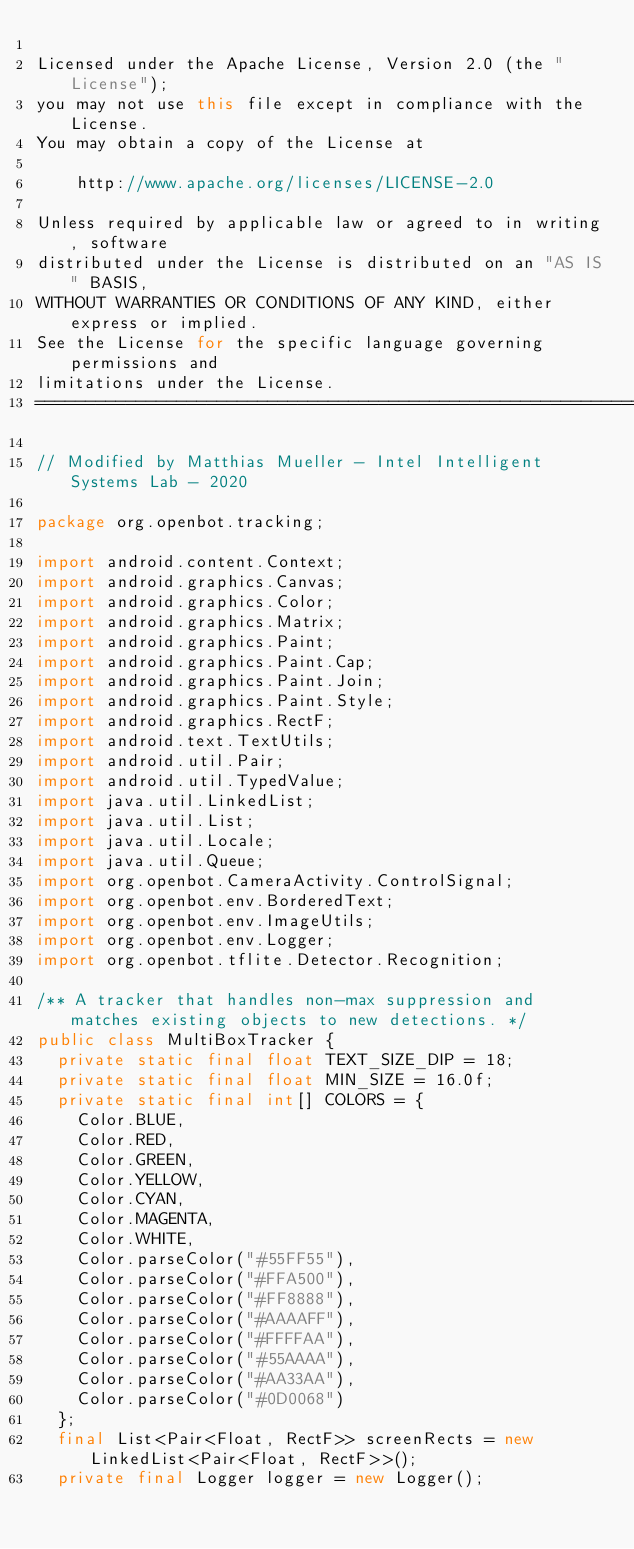<code> <loc_0><loc_0><loc_500><loc_500><_Java_>
Licensed under the Apache License, Version 2.0 (the "License");
you may not use this file except in compliance with the License.
You may obtain a copy of the License at

    http://www.apache.org/licenses/LICENSE-2.0

Unless required by applicable law or agreed to in writing, software
distributed under the License is distributed on an "AS IS" BASIS,
WITHOUT WARRANTIES OR CONDITIONS OF ANY KIND, either express or implied.
See the License for the specific language governing permissions and
limitations under the License.
==============================================================================*/

// Modified by Matthias Mueller - Intel Intelligent Systems Lab - 2020

package org.openbot.tracking;

import android.content.Context;
import android.graphics.Canvas;
import android.graphics.Color;
import android.graphics.Matrix;
import android.graphics.Paint;
import android.graphics.Paint.Cap;
import android.graphics.Paint.Join;
import android.graphics.Paint.Style;
import android.graphics.RectF;
import android.text.TextUtils;
import android.util.Pair;
import android.util.TypedValue;
import java.util.LinkedList;
import java.util.List;
import java.util.Locale;
import java.util.Queue;
import org.openbot.CameraActivity.ControlSignal;
import org.openbot.env.BorderedText;
import org.openbot.env.ImageUtils;
import org.openbot.env.Logger;
import org.openbot.tflite.Detector.Recognition;

/** A tracker that handles non-max suppression and matches existing objects to new detections. */
public class MultiBoxTracker {
  private static final float TEXT_SIZE_DIP = 18;
  private static final float MIN_SIZE = 16.0f;
  private static final int[] COLORS = {
    Color.BLUE,
    Color.RED,
    Color.GREEN,
    Color.YELLOW,
    Color.CYAN,
    Color.MAGENTA,
    Color.WHITE,
    Color.parseColor("#55FF55"),
    Color.parseColor("#FFA500"),
    Color.parseColor("#FF8888"),
    Color.parseColor("#AAAAFF"),
    Color.parseColor("#FFFFAA"),
    Color.parseColor("#55AAAA"),
    Color.parseColor("#AA33AA"),
    Color.parseColor("#0D0068")
  };
  final List<Pair<Float, RectF>> screenRects = new LinkedList<Pair<Float, RectF>>();
  private final Logger logger = new Logger();</code> 